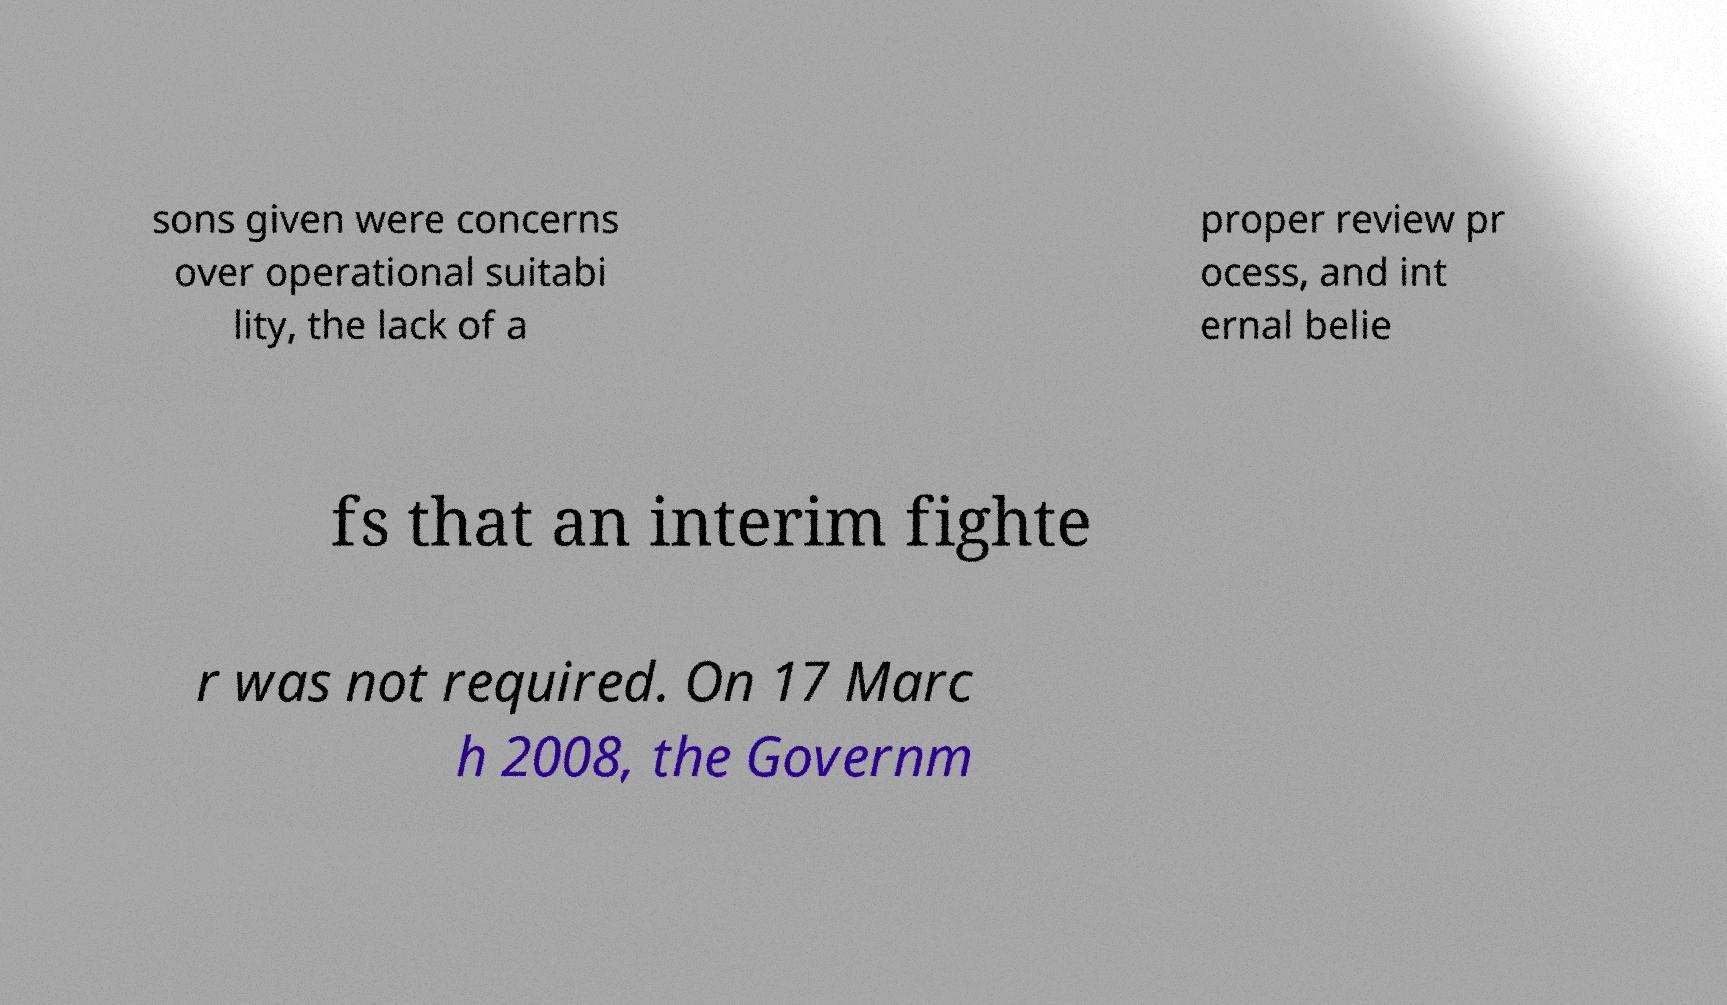Please identify and transcribe the text found in this image. sons given were concerns over operational suitabi lity, the lack of a proper review pr ocess, and int ernal belie fs that an interim fighte r was not required. On 17 Marc h 2008, the Governm 